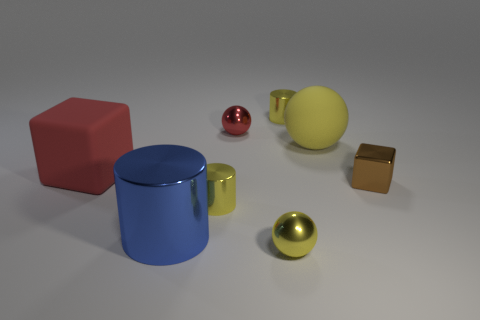What material is the tiny yellow ball?
Provide a short and direct response. Metal. How many rubber things have the same size as the red rubber block?
Make the answer very short. 1. Is the number of small objects behind the big red cube the same as the number of small metallic cylinders that are in front of the big yellow ball?
Offer a very short reply. No. Are the large blue object and the large yellow ball made of the same material?
Provide a short and direct response. No. Is there a big red rubber object that is to the left of the cube left of the blue metal thing?
Provide a succinct answer. No. Are there any tiny yellow shiny objects of the same shape as the large red rubber thing?
Your response must be concise. No. Do the matte cube and the shiny block have the same color?
Give a very brief answer. No. There is a tiny cylinder in front of the large matte thing behind the large red rubber block; what is it made of?
Offer a terse response. Metal. What is the size of the red rubber cube?
Your response must be concise. Large. There is a red object that is made of the same material as the big cylinder; what is its size?
Provide a succinct answer. Small. 